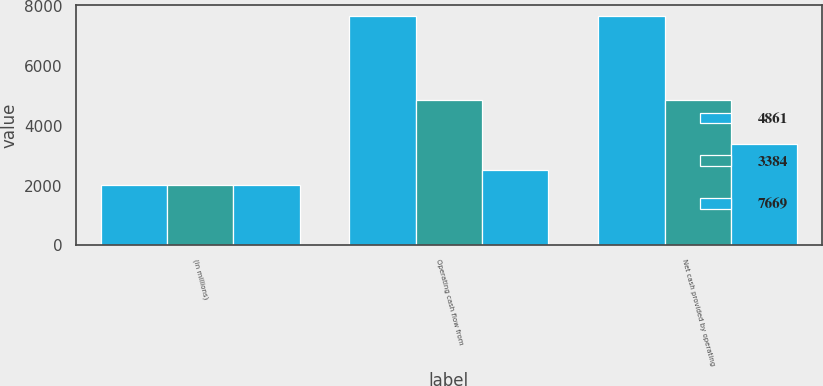Convert chart. <chart><loc_0><loc_0><loc_500><loc_500><stacked_bar_chart><ecel><fcel>(in millions)<fcel>Operating cash flow from<fcel>Net cash provided by operating<nl><fcel>4861<fcel>2018<fcel>7669<fcel>7669<nl><fcel>3384<fcel>2017<fcel>4861<fcel>4861<nl><fcel>7669<fcel>2016<fcel>2520<fcel>3384<nl></chart> 